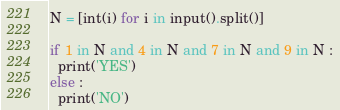Convert code to text. <code><loc_0><loc_0><loc_500><loc_500><_Python_>N = [int(i) for i in input().split()]

if 1 in N and 4 in N and 7 in N and 9 in N :
  print('YES')
else :
  print('NO')</code> 